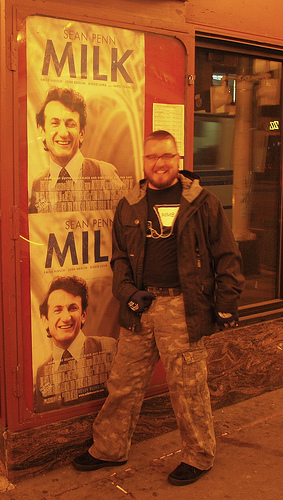<image>
Is there a man to the left of the poster? No. The man is not to the left of the poster. From this viewpoint, they have a different horizontal relationship. 